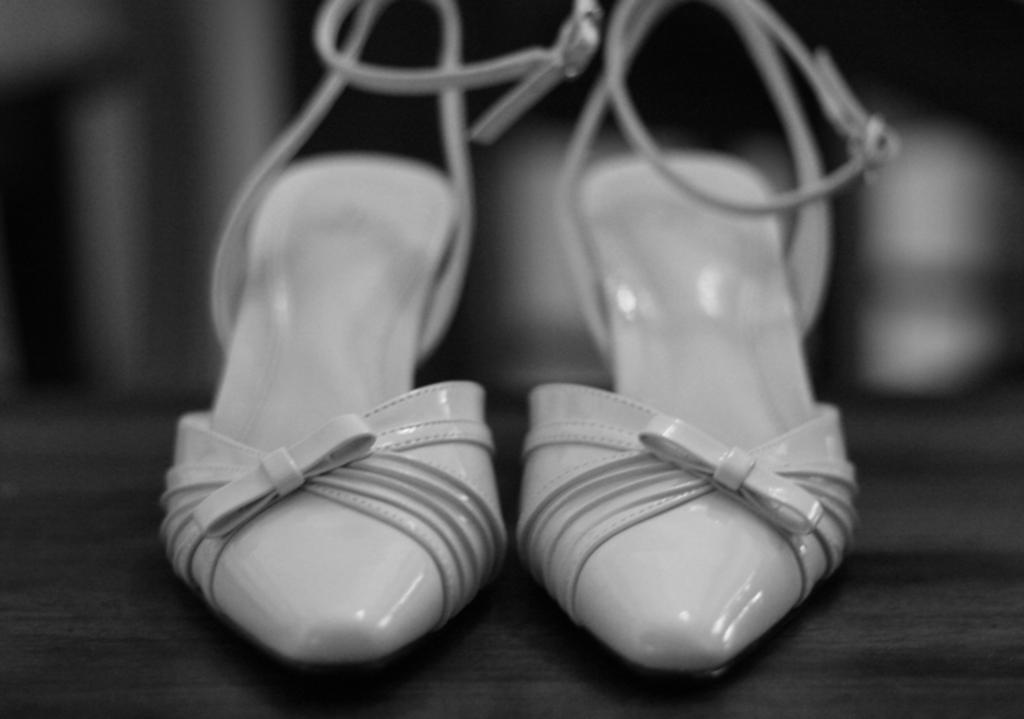What is the color scheme of the image? The image is black and white. What is the main object in the center of the image? There are sand heels in the center of the image. Where are the sand heels located? The sand heels are on the floor. Can you describe the background of the image? The background of the image is blurry. What type of test can be seen being conducted on the wire in the image? There is no test or wire present in the image; it features sand heels on the floor with a blurry background. What substance is being used to create the sand heels in the image? There is no indication of the substance used to create the sand heels in the image. 